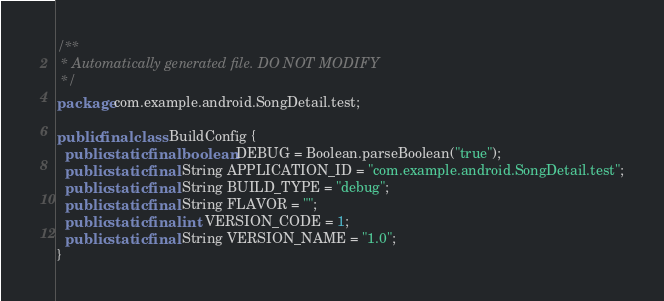Convert code to text. <code><loc_0><loc_0><loc_500><loc_500><_Java_>/**
 * Automatically generated file. DO NOT MODIFY
 */
package com.example.android.SongDetail.test;

public final class BuildConfig {
  public static final boolean DEBUG = Boolean.parseBoolean("true");
  public static final String APPLICATION_ID = "com.example.android.SongDetail.test";
  public static final String BUILD_TYPE = "debug";
  public static final String FLAVOR = "";
  public static final int VERSION_CODE = 1;
  public static final String VERSION_NAME = "1.0";
}
</code> 